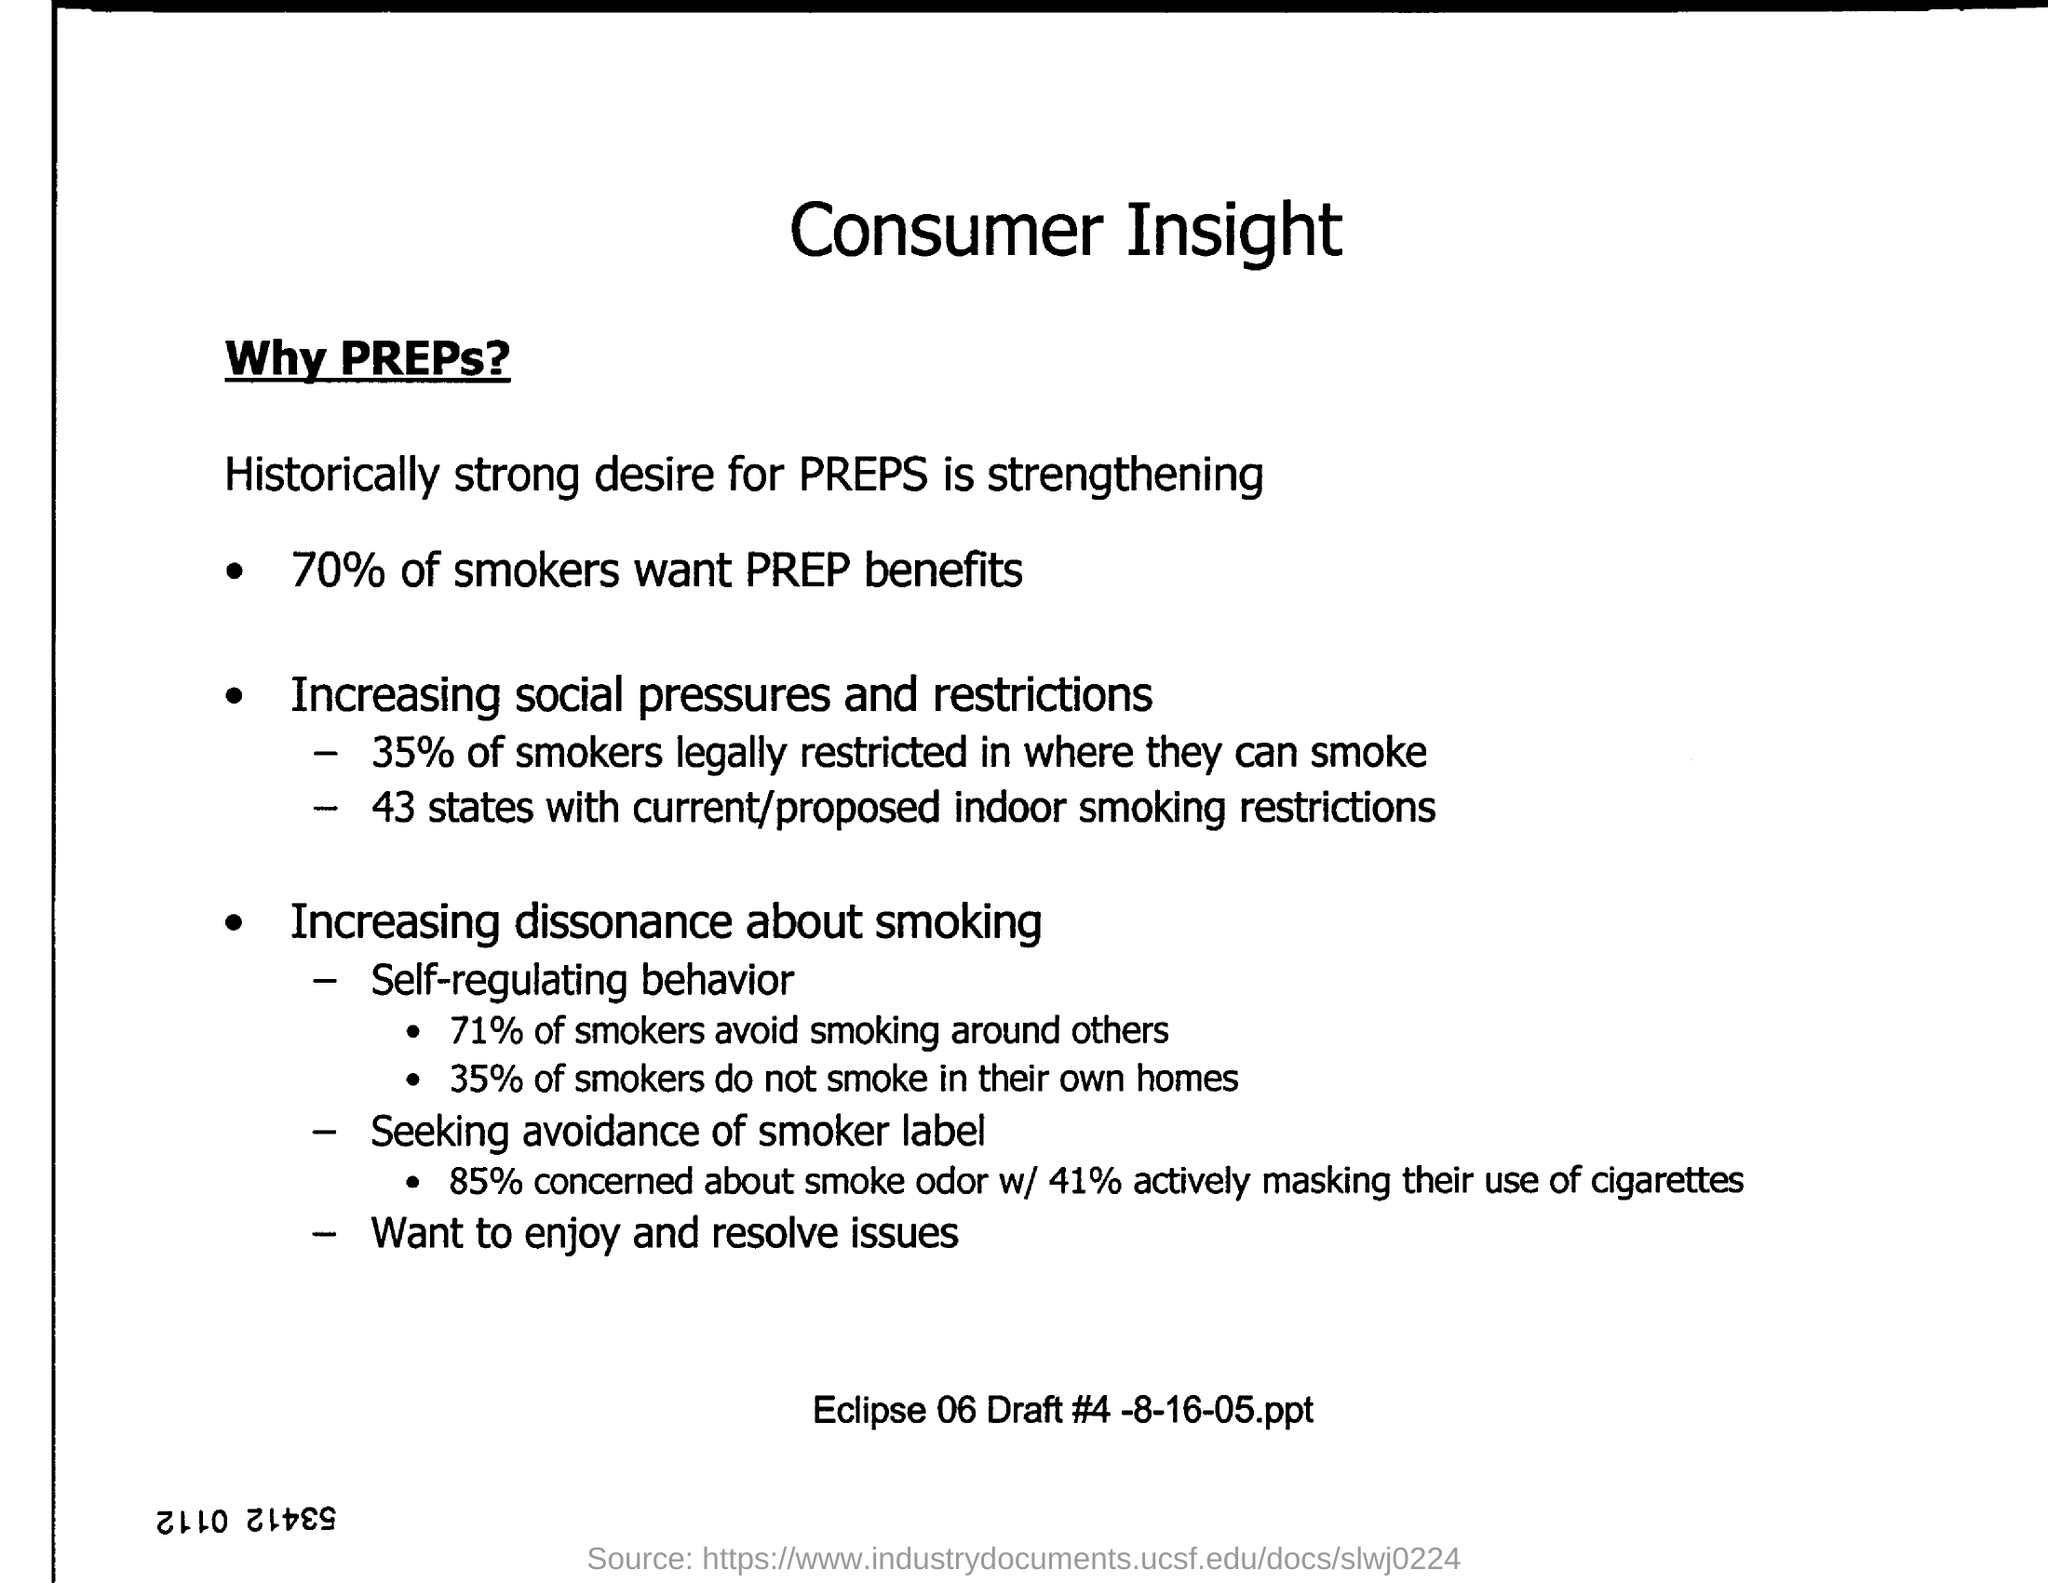What behaviors are smokers adopting to mitigate the social impact of smoking? As depicted in the image, smokers are increasingly adopting self-regulating behaviors to lessen the social impact of their habit. Notably, 71% avoid smoking around others, and 35% choose not to smoke in their own homes. Is there an indication that smokers are concerned about the smoker label or smoke odor? Indeed, the information suggests that there's a significant concern about the smoker label and smoke odor. A substantial 85% of smokers are worried about smoke odor, with 41% actively trying to mask their cigarette use to avoid being labeled as smokers. 